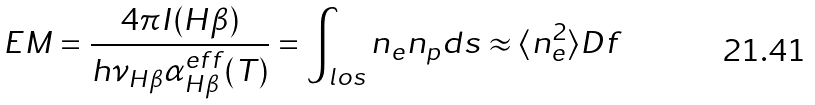Convert formula to latex. <formula><loc_0><loc_0><loc_500><loc_500>E M = \frac { 4 \pi I ( H \beta ) } { h \nu _ { H \beta } \alpha _ { H \beta } ^ { e f f } ( T ) } = \int _ { l o s } n _ { e } n _ { p } d s \approx \langle n _ { e } ^ { 2 } \rangle D f</formula> 